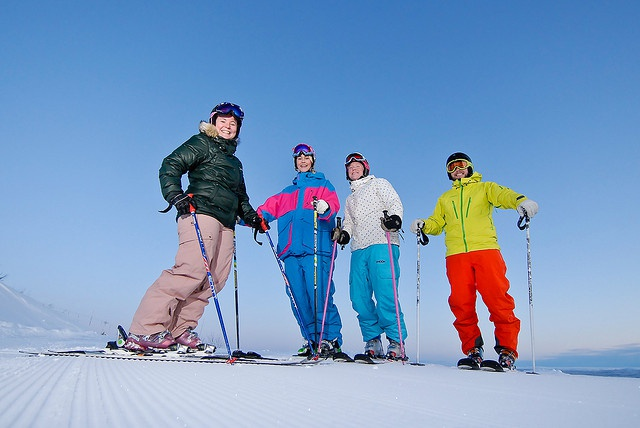Describe the objects in this image and their specific colors. I can see people in gray, black, pink, and darkgray tones, people in gray, red, khaki, and brown tones, people in gray, blue, black, and magenta tones, people in gray, lightgray, and teal tones, and skis in gray, lightgray, black, and darkgray tones in this image. 